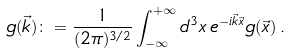<formula> <loc_0><loc_0><loc_500><loc_500>g ( \vec { k } ) \colon = \frac { 1 } { ( 2 \pi ) ^ { 3 / 2 } } \int _ { - \infty } ^ { + \infty } d ^ { 3 } x \, e ^ { - i \vec { k } \vec { x } } g ( \vec { x } ) \, .</formula> 